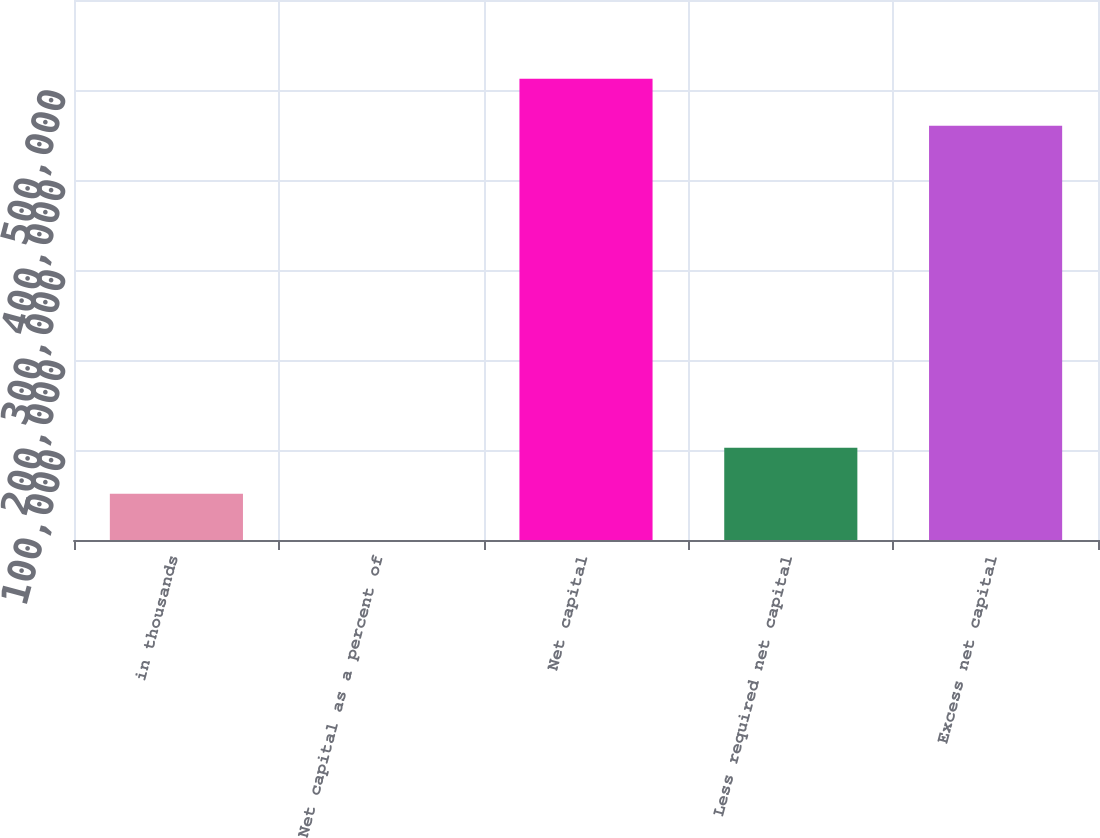Convert chart to OTSL. <chart><loc_0><loc_0><loc_500><loc_500><bar_chart><fcel>in thousands<fcel>Net capital as a percent of<fcel>Net capital<fcel>Less required net capital<fcel>Excess net capital<nl><fcel>51277.1<fcel>19.61<fcel>512594<fcel>102534<fcel>460307<nl></chart> 